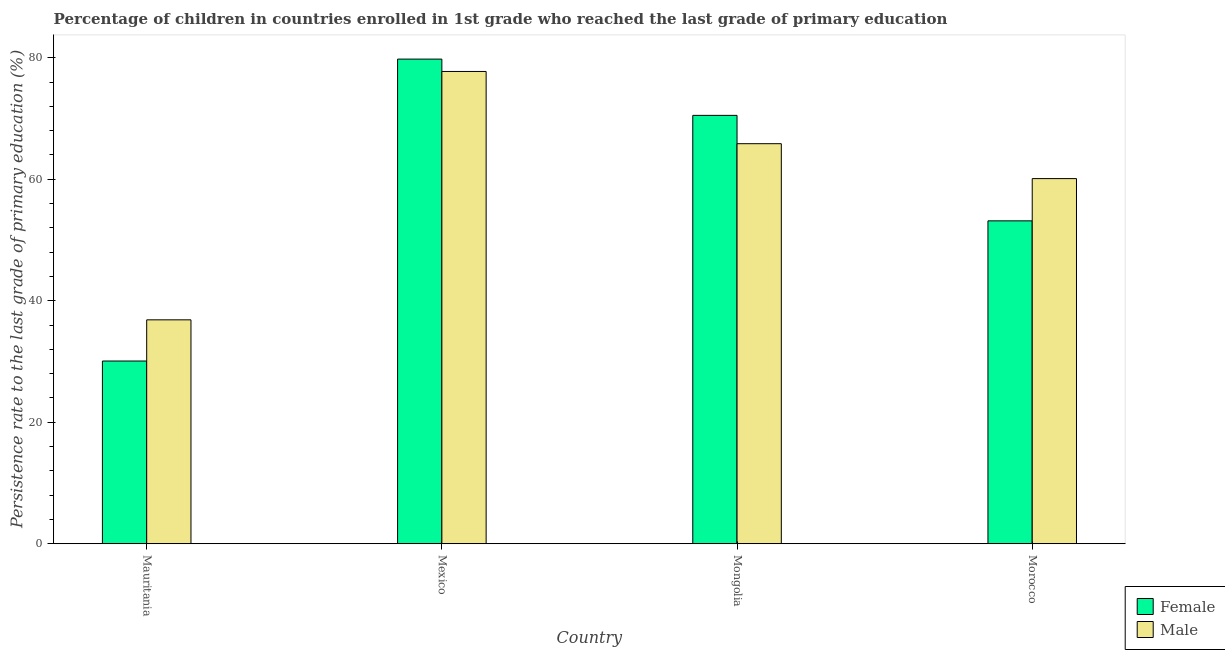How many different coloured bars are there?
Your answer should be very brief. 2. How many groups of bars are there?
Your answer should be very brief. 4. How many bars are there on the 2nd tick from the right?
Provide a short and direct response. 2. What is the label of the 1st group of bars from the left?
Ensure brevity in your answer.  Mauritania. What is the persistence rate of female students in Mongolia?
Your answer should be very brief. 70.51. Across all countries, what is the maximum persistence rate of female students?
Provide a short and direct response. 79.77. Across all countries, what is the minimum persistence rate of male students?
Provide a succinct answer. 36.85. In which country was the persistence rate of female students minimum?
Your answer should be very brief. Mauritania. What is the total persistence rate of male students in the graph?
Provide a short and direct response. 240.54. What is the difference between the persistence rate of female students in Mauritania and that in Morocco?
Keep it short and to the point. -23.07. What is the difference between the persistence rate of male students in Mauritania and the persistence rate of female students in Morocco?
Ensure brevity in your answer.  -16.29. What is the average persistence rate of male students per country?
Offer a terse response. 60.13. What is the difference between the persistence rate of male students and persistence rate of female students in Mongolia?
Provide a short and direct response. -4.66. What is the ratio of the persistence rate of male students in Mauritania to that in Mongolia?
Offer a very short reply. 0.56. What is the difference between the highest and the second highest persistence rate of female students?
Your answer should be very brief. 9.26. What is the difference between the highest and the lowest persistence rate of male students?
Provide a short and direct response. 40.88. In how many countries, is the persistence rate of female students greater than the average persistence rate of female students taken over all countries?
Provide a succinct answer. 2. Is the sum of the persistence rate of male students in Mauritania and Morocco greater than the maximum persistence rate of female students across all countries?
Keep it short and to the point. Yes. Does the graph contain any zero values?
Ensure brevity in your answer.  No. Does the graph contain grids?
Your answer should be very brief. No. Where does the legend appear in the graph?
Keep it short and to the point. Bottom right. What is the title of the graph?
Ensure brevity in your answer.  Percentage of children in countries enrolled in 1st grade who reached the last grade of primary education. Does "Male entrants" appear as one of the legend labels in the graph?
Make the answer very short. No. What is the label or title of the Y-axis?
Offer a very short reply. Persistence rate to the last grade of primary education (%). What is the Persistence rate to the last grade of primary education (%) in Female in Mauritania?
Your response must be concise. 30.07. What is the Persistence rate to the last grade of primary education (%) of Male in Mauritania?
Offer a terse response. 36.85. What is the Persistence rate to the last grade of primary education (%) in Female in Mexico?
Give a very brief answer. 79.77. What is the Persistence rate to the last grade of primary education (%) of Male in Mexico?
Ensure brevity in your answer.  77.74. What is the Persistence rate to the last grade of primary education (%) of Female in Mongolia?
Your response must be concise. 70.51. What is the Persistence rate to the last grade of primary education (%) in Male in Mongolia?
Offer a terse response. 65.85. What is the Persistence rate to the last grade of primary education (%) in Female in Morocco?
Provide a succinct answer. 53.15. What is the Persistence rate to the last grade of primary education (%) of Male in Morocco?
Provide a short and direct response. 60.1. Across all countries, what is the maximum Persistence rate to the last grade of primary education (%) in Female?
Provide a succinct answer. 79.77. Across all countries, what is the maximum Persistence rate to the last grade of primary education (%) in Male?
Provide a short and direct response. 77.74. Across all countries, what is the minimum Persistence rate to the last grade of primary education (%) in Female?
Keep it short and to the point. 30.07. Across all countries, what is the minimum Persistence rate to the last grade of primary education (%) of Male?
Make the answer very short. 36.85. What is the total Persistence rate to the last grade of primary education (%) of Female in the graph?
Provide a succinct answer. 233.5. What is the total Persistence rate to the last grade of primary education (%) in Male in the graph?
Offer a terse response. 240.54. What is the difference between the Persistence rate to the last grade of primary education (%) in Female in Mauritania and that in Mexico?
Offer a very short reply. -49.7. What is the difference between the Persistence rate to the last grade of primary education (%) of Male in Mauritania and that in Mexico?
Offer a very short reply. -40.88. What is the difference between the Persistence rate to the last grade of primary education (%) in Female in Mauritania and that in Mongolia?
Give a very brief answer. -40.44. What is the difference between the Persistence rate to the last grade of primary education (%) in Male in Mauritania and that in Mongolia?
Provide a succinct answer. -28.99. What is the difference between the Persistence rate to the last grade of primary education (%) in Female in Mauritania and that in Morocco?
Your answer should be compact. -23.07. What is the difference between the Persistence rate to the last grade of primary education (%) of Male in Mauritania and that in Morocco?
Your response must be concise. -23.25. What is the difference between the Persistence rate to the last grade of primary education (%) of Female in Mexico and that in Mongolia?
Give a very brief answer. 9.26. What is the difference between the Persistence rate to the last grade of primary education (%) in Male in Mexico and that in Mongolia?
Ensure brevity in your answer.  11.89. What is the difference between the Persistence rate to the last grade of primary education (%) of Female in Mexico and that in Morocco?
Provide a succinct answer. 26.62. What is the difference between the Persistence rate to the last grade of primary education (%) in Male in Mexico and that in Morocco?
Give a very brief answer. 17.63. What is the difference between the Persistence rate to the last grade of primary education (%) in Female in Mongolia and that in Morocco?
Ensure brevity in your answer.  17.36. What is the difference between the Persistence rate to the last grade of primary education (%) in Male in Mongolia and that in Morocco?
Your answer should be compact. 5.75. What is the difference between the Persistence rate to the last grade of primary education (%) of Female in Mauritania and the Persistence rate to the last grade of primary education (%) of Male in Mexico?
Keep it short and to the point. -47.66. What is the difference between the Persistence rate to the last grade of primary education (%) in Female in Mauritania and the Persistence rate to the last grade of primary education (%) in Male in Mongolia?
Keep it short and to the point. -35.77. What is the difference between the Persistence rate to the last grade of primary education (%) in Female in Mauritania and the Persistence rate to the last grade of primary education (%) in Male in Morocco?
Your answer should be compact. -30.03. What is the difference between the Persistence rate to the last grade of primary education (%) in Female in Mexico and the Persistence rate to the last grade of primary education (%) in Male in Mongolia?
Make the answer very short. 13.92. What is the difference between the Persistence rate to the last grade of primary education (%) of Female in Mexico and the Persistence rate to the last grade of primary education (%) of Male in Morocco?
Your answer should be very brief. 19.67. What is the difference between the Persistence rate to the last grade of primary education (%) of Female in Mongolia and the Persistence rate to the last grade of primary education (%) of Male in Morocco?
Ensure brevity in your answer.  10.41. What is the average Persistence rate to the last grade of primary education (%) in Female per country?
Your answer should be compact. 58.38. What is the average Persistence rate to the last grade of primary education (%) in Male per country?
Your answer should be very brief. 60.13. What is the difference between the Persistence rate to the last grade of primary education (%) of Female and Persistence rate to the last grade of primary education (%) of Male in Mauritania?
Keep it short and to the point. -6.78. What is the difference between the Persistence rate to the last grade of primary education (%) of Female and Persistence rate to the last grade of primary education (%) of Male in Mexico?
Your answer should be compact. 2.03. What is the difference between the Persistence rate to the last grade of primary education (%) in Female and Persistence rate to the last grade of primary education (%) in Male in Mongolia?
Your response must be concise. 4.66. What is the difference between the Persistence rate to the last grade of primary education (%) in Female and Persistence rate to the last grade of primary education (%) in Male in Morocco?
Your response must be concise. -6.95. What is the ratio of the Persistence rate to the last grade of primary education (%) in Female in Mauritania to that in Mexico?
Provide a short and direct response. 0.38. What is the ratio of the Persistence rate to the last grade of primary education (%) in Male in Mauritania to that in Mexico?
Offer a very short reply. 0.47. What is the ratio of the Persistence rate to the last grade of primary education (%) in Female in Mauritania to that in Mongolia?
Give a very brief answer. 0.43. What is the ratio of the Persistence rate to the last grade of primary education (%) of Male in Mauritania to that in Mongolia?
Your response must be concise. 0.56. What is the ratio of the Persistence rate to the last grade of primary education (%) of Female in Mauritania to that in Morocco?
Provide a succinct answer. 0.57. What is the ratio of the Persistence rate to the last grade of primary education (%) in Male in Mauritania to that in Morocco?
Give a very brief answer. 0.61. What is the ratio of the Persistence rate to the last grade of primary education (%) in Female in Mexico to that in Mongolia?
Your response must be concise. 1.13. What is the ratio of the Persistence rate to the last grade of primary education (%) in Male in Mexico to that in Mongolia?
Give a very brief answer. 1.18. What is the ratio of the Persistence rate to the last grade of primary education (%) of Female in Mexico to that in Morocco?
Provide a short and direct response. 1.5. What is the ratio of the Persistence rate to the last grade of primary education (%) of Male in Mexico to that in Morocco?
Offer a terse response. 1.29. What is the ratio of the Persistence rate to the last grade of primary education (%) of Female in Mongolia to that in Morocco?
Provide a succinct answer. 1.33. What is the ratio of the Persistence rate to the last grade of primary education (%) in Male in Mongolia to that in Morocco?
Ensure brevity in your answer.  1.1. What is the difference between the highest and the second highest Persistence rate to the last grade of primary education (%) of Female?
Your answer should be very brief. 9.26. What is the difference between the highest and the second highest Persistence rate to the last grade of primary education (%) in Male?
Offer a very short reply. 11.89. What is the difference between the highest and the lowest Persistence rate to the last grade of primary education (%) in Female?
Keep it short and to the point. 49.7. What is the difference between the highest and the lowest Persistence rate to the last grade of primary education (%) of Male?
Provide a succinct answer. 40.88. 